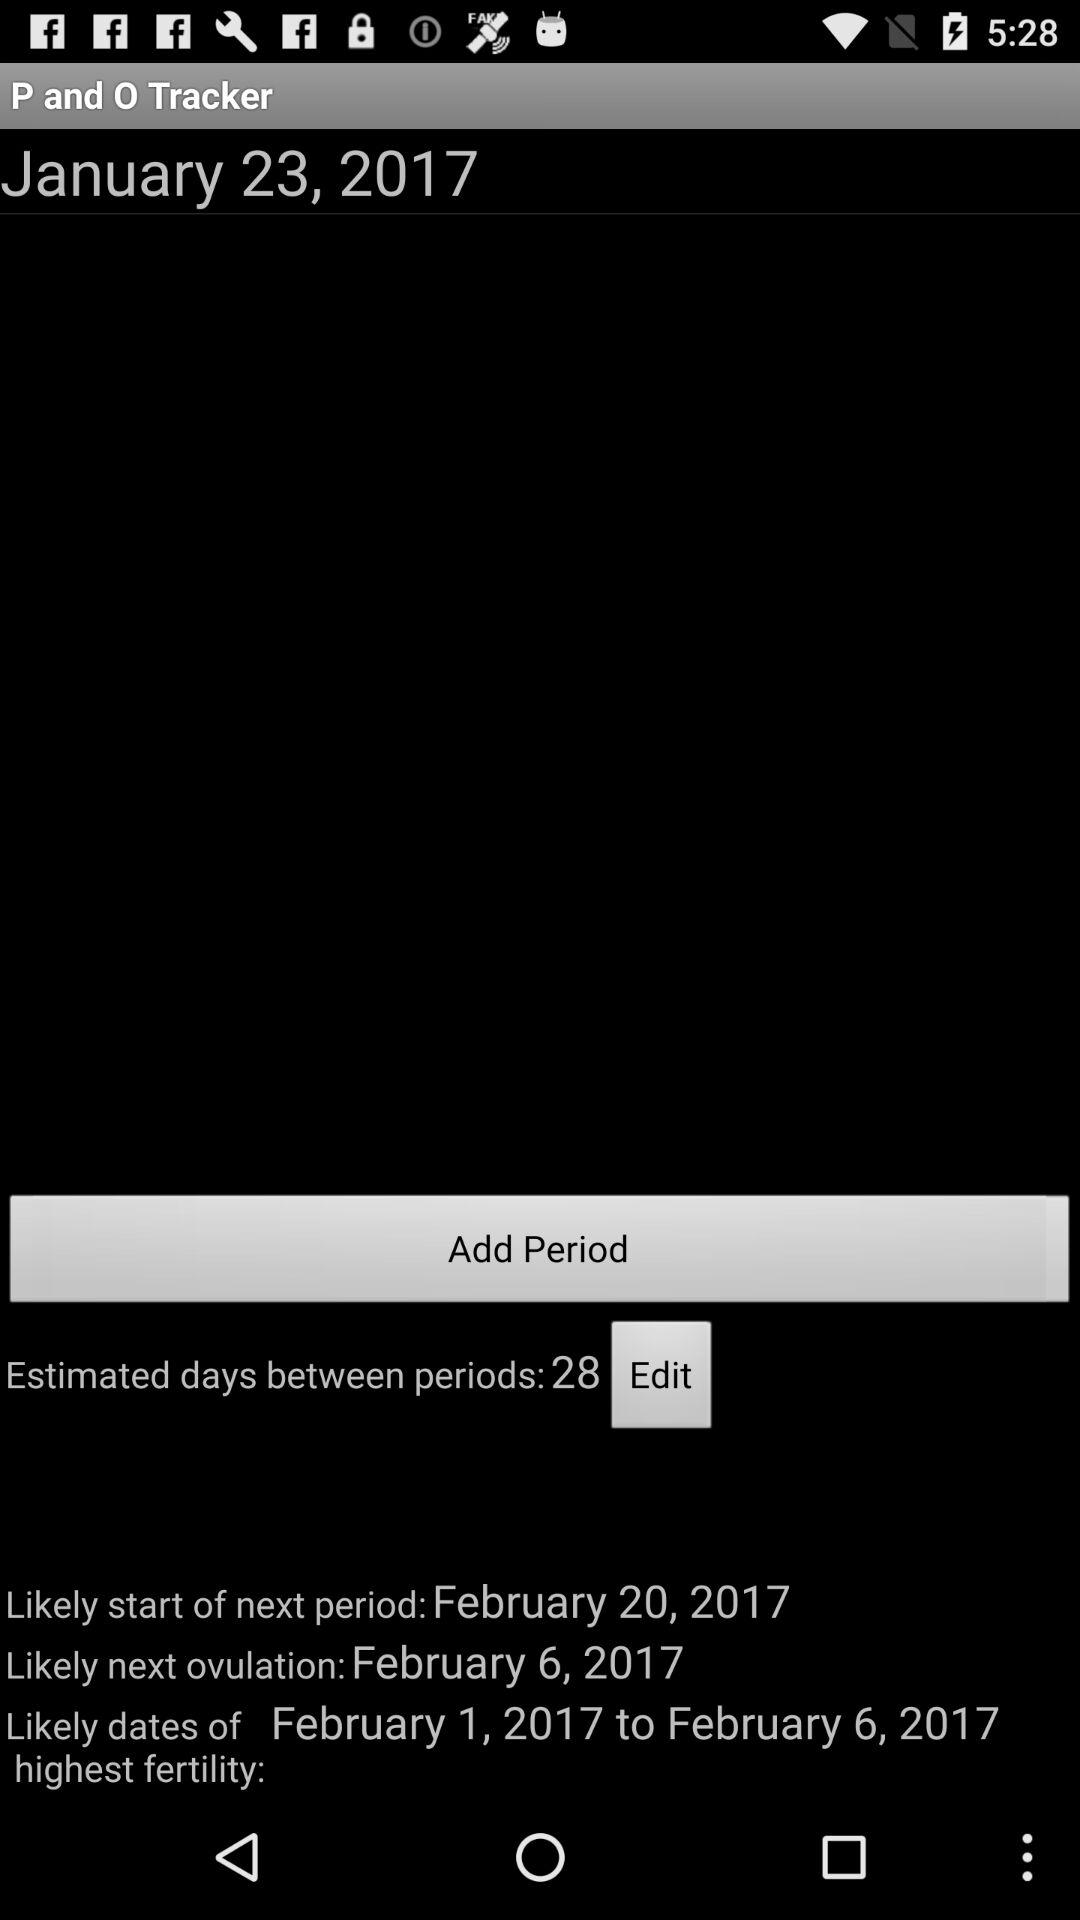What are the likely dates of the highest fertility? The likely dates of the highest fertility are from February 1, 2017 to February 6, 2017. 